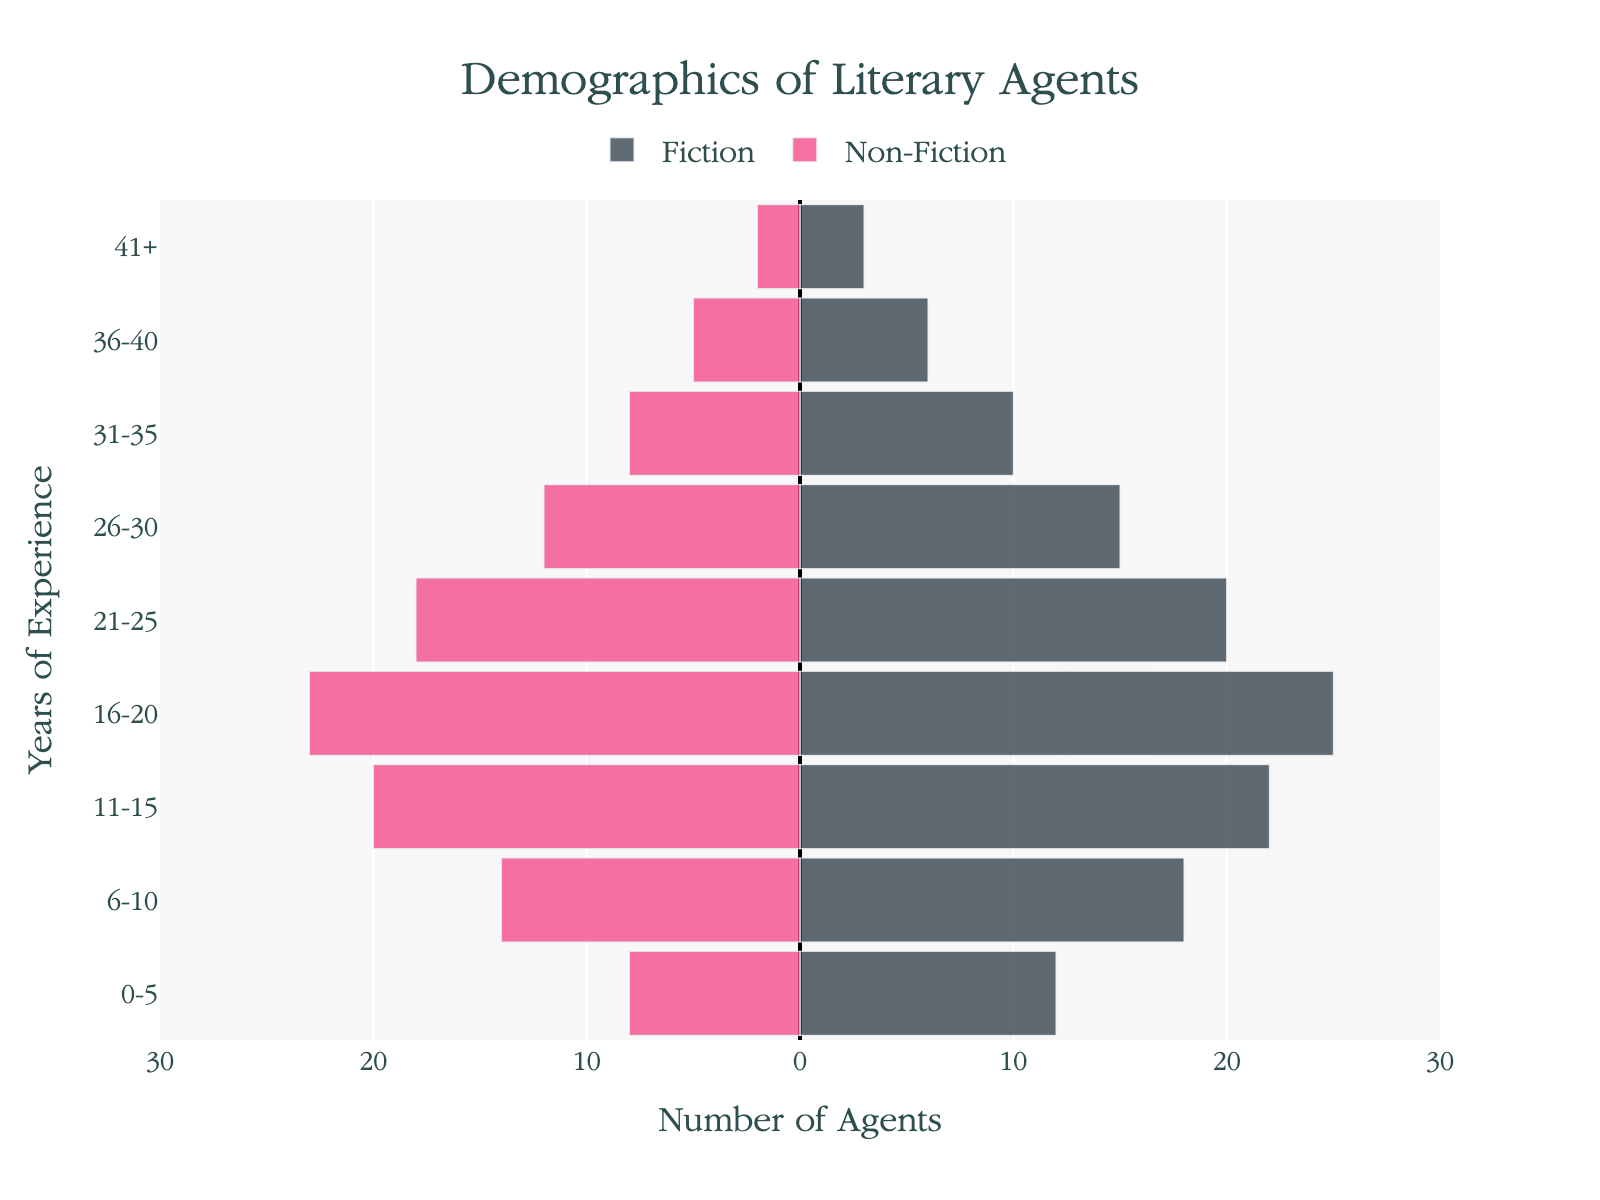What is the title of the figure? The title is usually displayed prominently at the top. It reads "Demographics of Literary Agents" in this case.
Answer: Demographics of Literary Agents What color represents Fiction agents in the figure? The color for Fiction agents is a specific shade found in the bars representing Fiction. It is 'rgba(58, 71, 80, 0.8)', which appears as a dark grayish-blue.
Answer: Dark grayish-blue How many Non-Fiction agents have 6-10 years of experience? Check the bar for Non-Fiction agents corresponding to 6-10 years of experience. The bar extends to -14, indicating 14 Non-Fiction agents.
Answer: 14 Which group has the highest number of agents in the 16-20 years of experience range? Compare the lengths of the Fiction and Non-Fiction bars for the 16-20 years range. Fiction has 25 agents, while Non-Fiction has 23. Therefore, Fiction has the higher count.
Answer: Fiction What is the total number of Fiction agents with more than 20 years of experience? Sum the Fiction agents in the 21-25, 26-30, 31-35, 36-40, and 41+ year ranges: 20 + 15 + 10 + 6 + 3 = 54.
Answer: 54 How many more Fiction agents are there than Non-Fiction agents with 16-20 years of experience? Fiction has 25 agents and Non-Fiction has 23 in the 16-20 years range. The difference is 25 - 23 = 2.
Answer: 2 What is the average number of Fiction agents across all experience ranges? Sum the Fiction agents (12 + 18 + 22 + 25 + 20 + 15 + 10 + 6 + 3) = 131, and divide by the number of ranges (9). So, 131 / 9 ≈ 14.56.
Answer: 14.56 What range has the smallest difference in numbers between Fiction and Non-Fiction agents? Calculate the absolute difference in each range: 
0-5 (4), 6-10 (4), 11-15 (2), 16-20 (2), 21-25 (2), 26-30 (3), 31-35 (2), 36-40 (1), 41+ (1). The smallest differences are in 36-40 and 41+ (1).
Answer: 36-40 and 41+ What is the total number of Non-Fiction agents with less than 16 years of experience? Sum the Non-Fiction agents in the 0-5, 6-10, and 11-15 year ranges: 8 + 14 + 20 = 42.
Answer: 42 